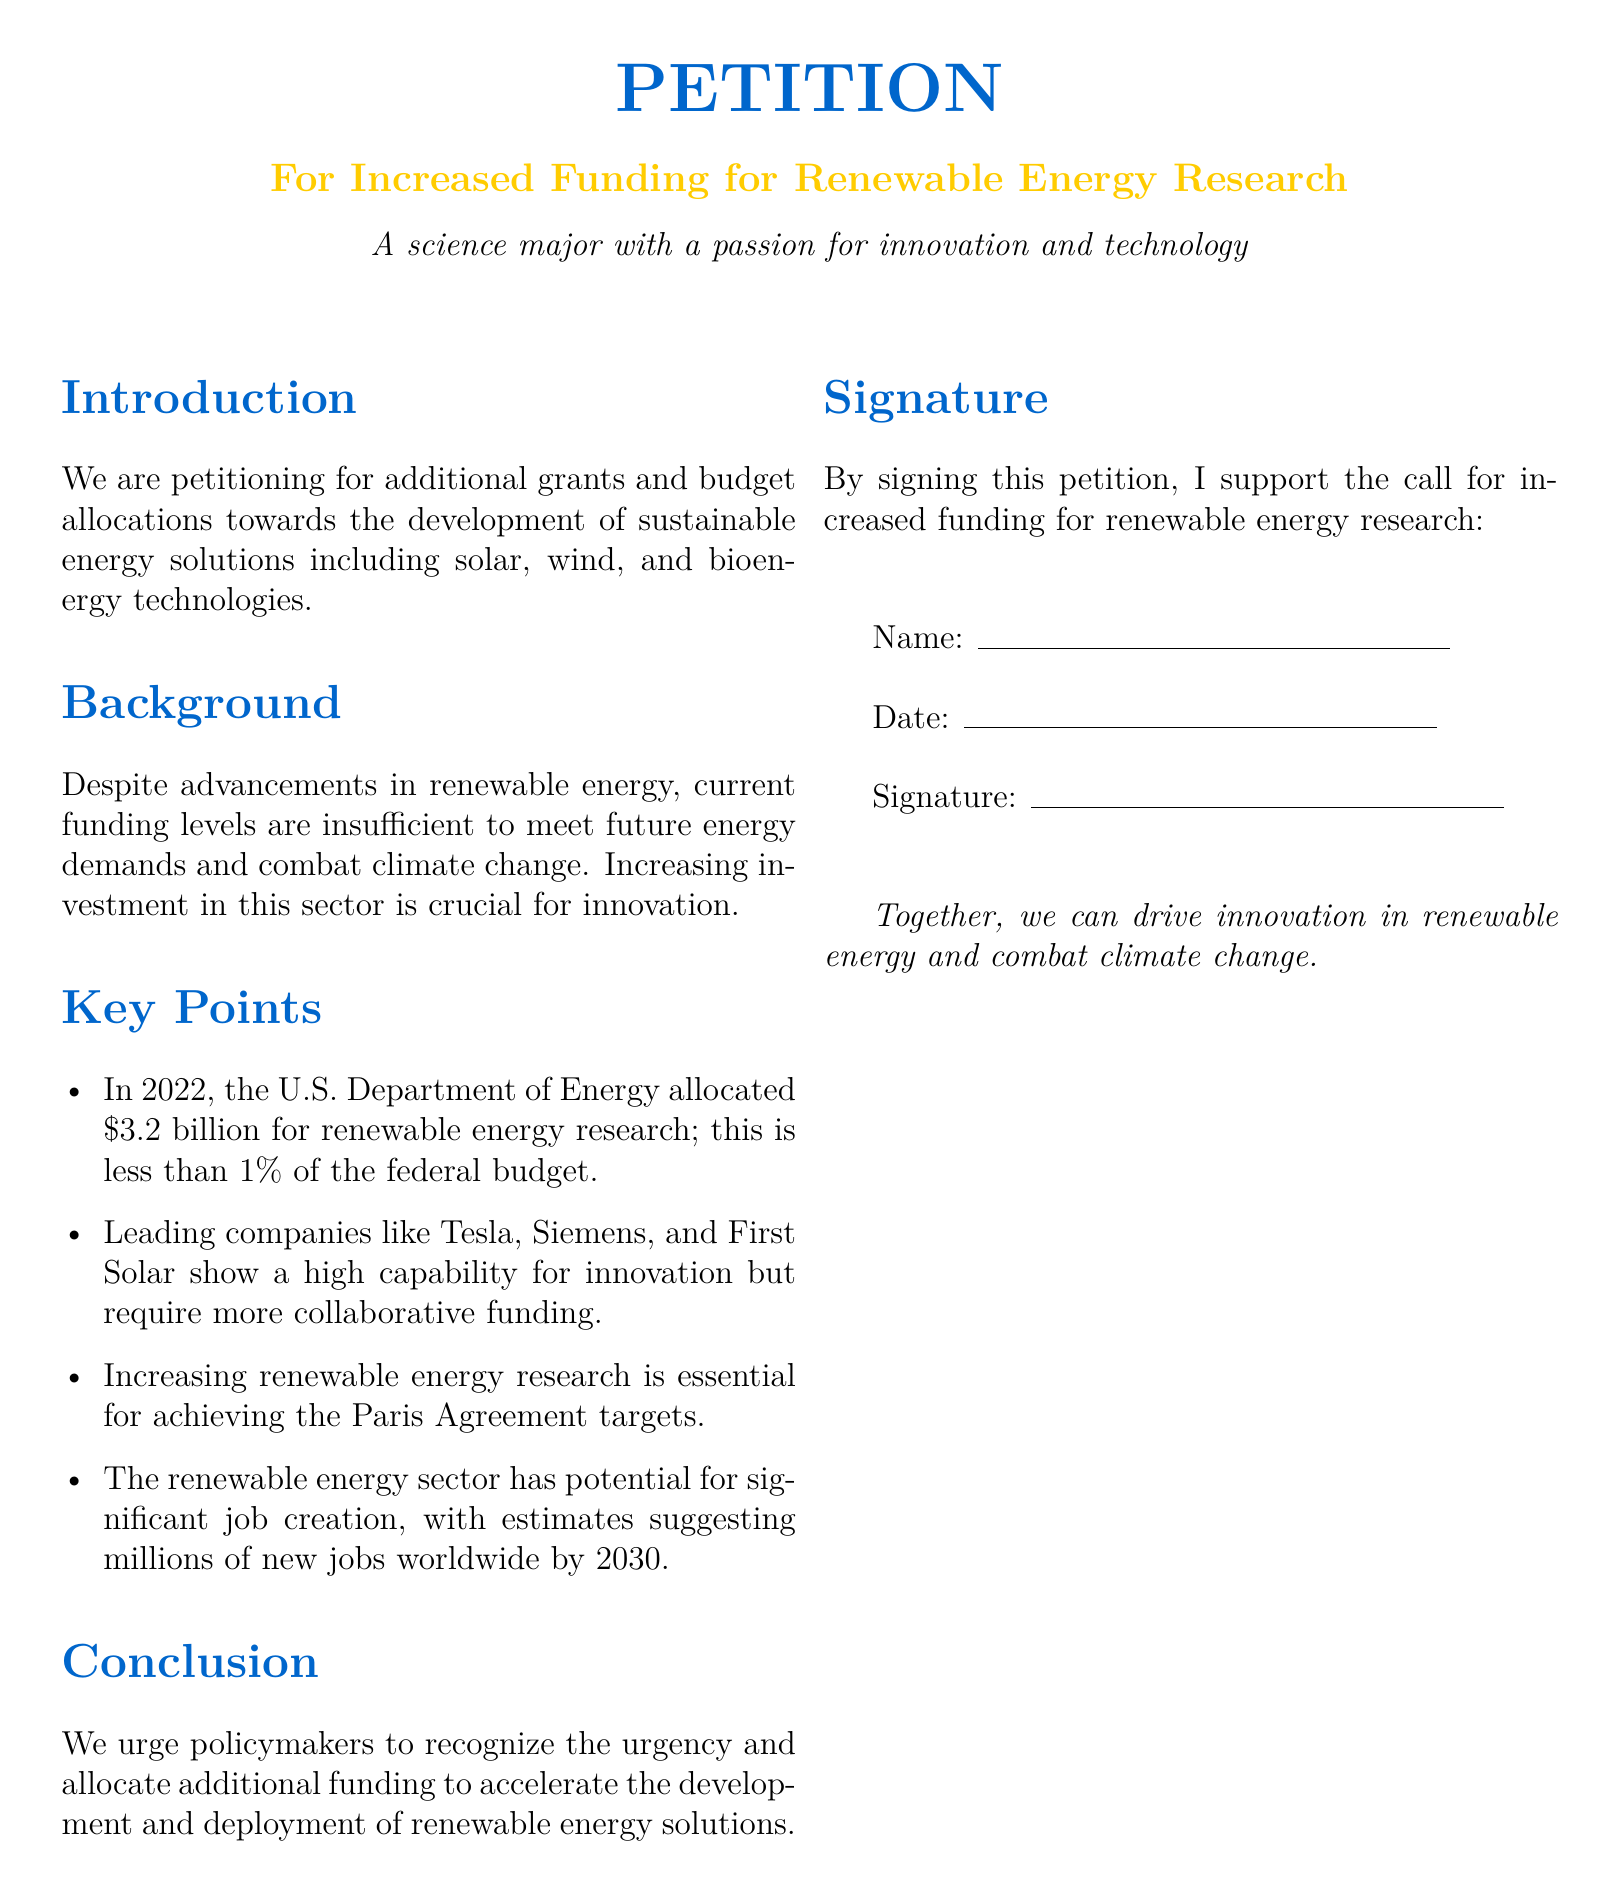What is the title of the petition? The title of the petition is specifically mentioned in the document as the proposed subject.
Answer: For Increased Funding for Renewable Energy Research How much did the U.S. Department of Energy allocate for renewable energy research in 2022? The document provides a specific funding amount as evidence for the petition's argument.
Answer: $3.2 billion What percentage of the federal budget does the renewable energy funding represent? This percentage is highlighted in the document to emphasize the need for more funding.
Answer: less than 1% What is one company mentioned that is capable of innovation in renewable energy? The document lists leading companies demonstrating innovation in the renewable energy sector.
Answer: Tesla By what year are millions of new jobs expected to be created in the renewable energy sector? The document anticipates future job creation, providing a specific timeline.
Answer: 2030 What action is urged upon policymakers in the conclusion? The conclusion of the petition calls for a specific action from the policymakers.
Answer: Allocate additional funding What does signing the petition support? The purpose of signing is stated to clarify the intention behind the petition.
Answer: Increased funding for renewable energy research What is the primary focus area of the research proposed in the petition? The main research areas are specified as part of the petition's request.
Answer: Sustainable energy solutions 